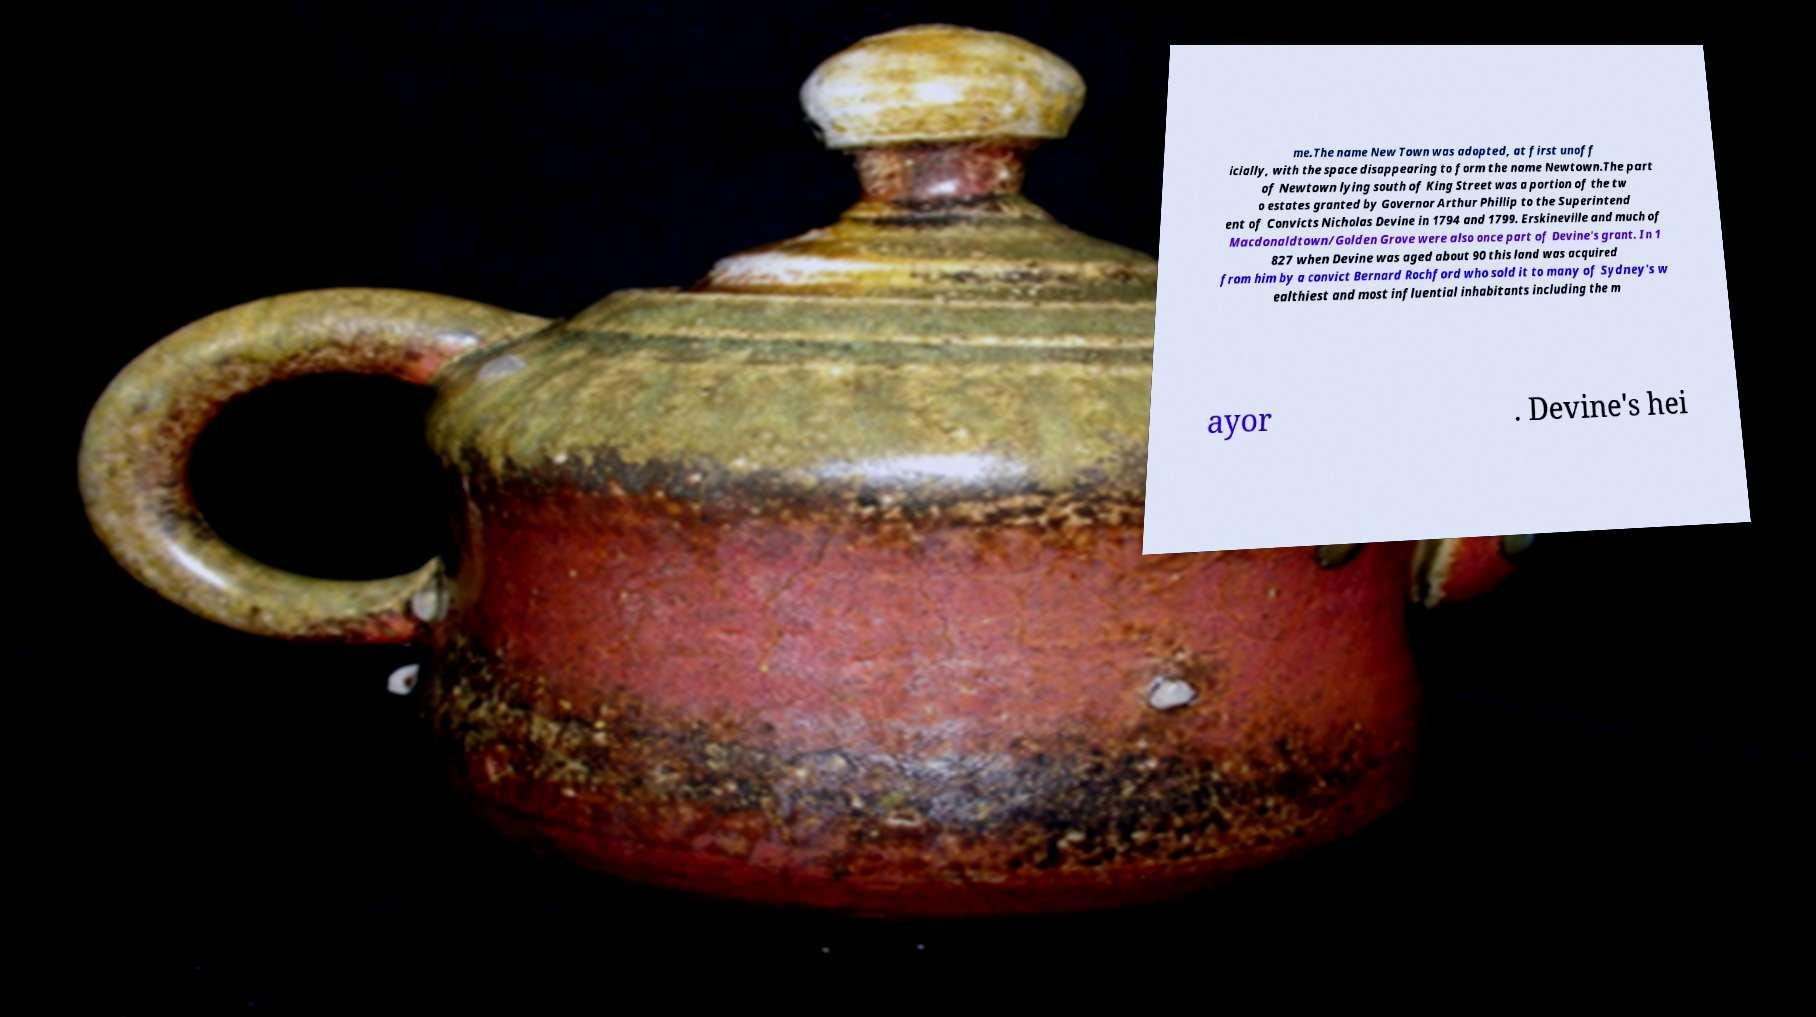Can you read and provide the text displayed in the image?This photo seems to have some interesting text. Can you extract and type it out for me? me.The name New Town was adopted, at first unoff icially, with the space disappearing to form the name Newtown.The part of Newtown lying south of King Street was a portion of the tw o estates granted by Governor Arthur Phillip to the Superintend ent of Convicts Nicholas Devine in 1794 and 1799. Erskineville and much of Macdonaldtown/Golden Grove were also once part of Devine's grant. In 1 827 when Devine was aged about 90 this land was acquired from him by a convict Bernard Rochford who sold it to many of Sydney's w ealthiest and most influential inhabitants including the m ayor . Devine's hei 